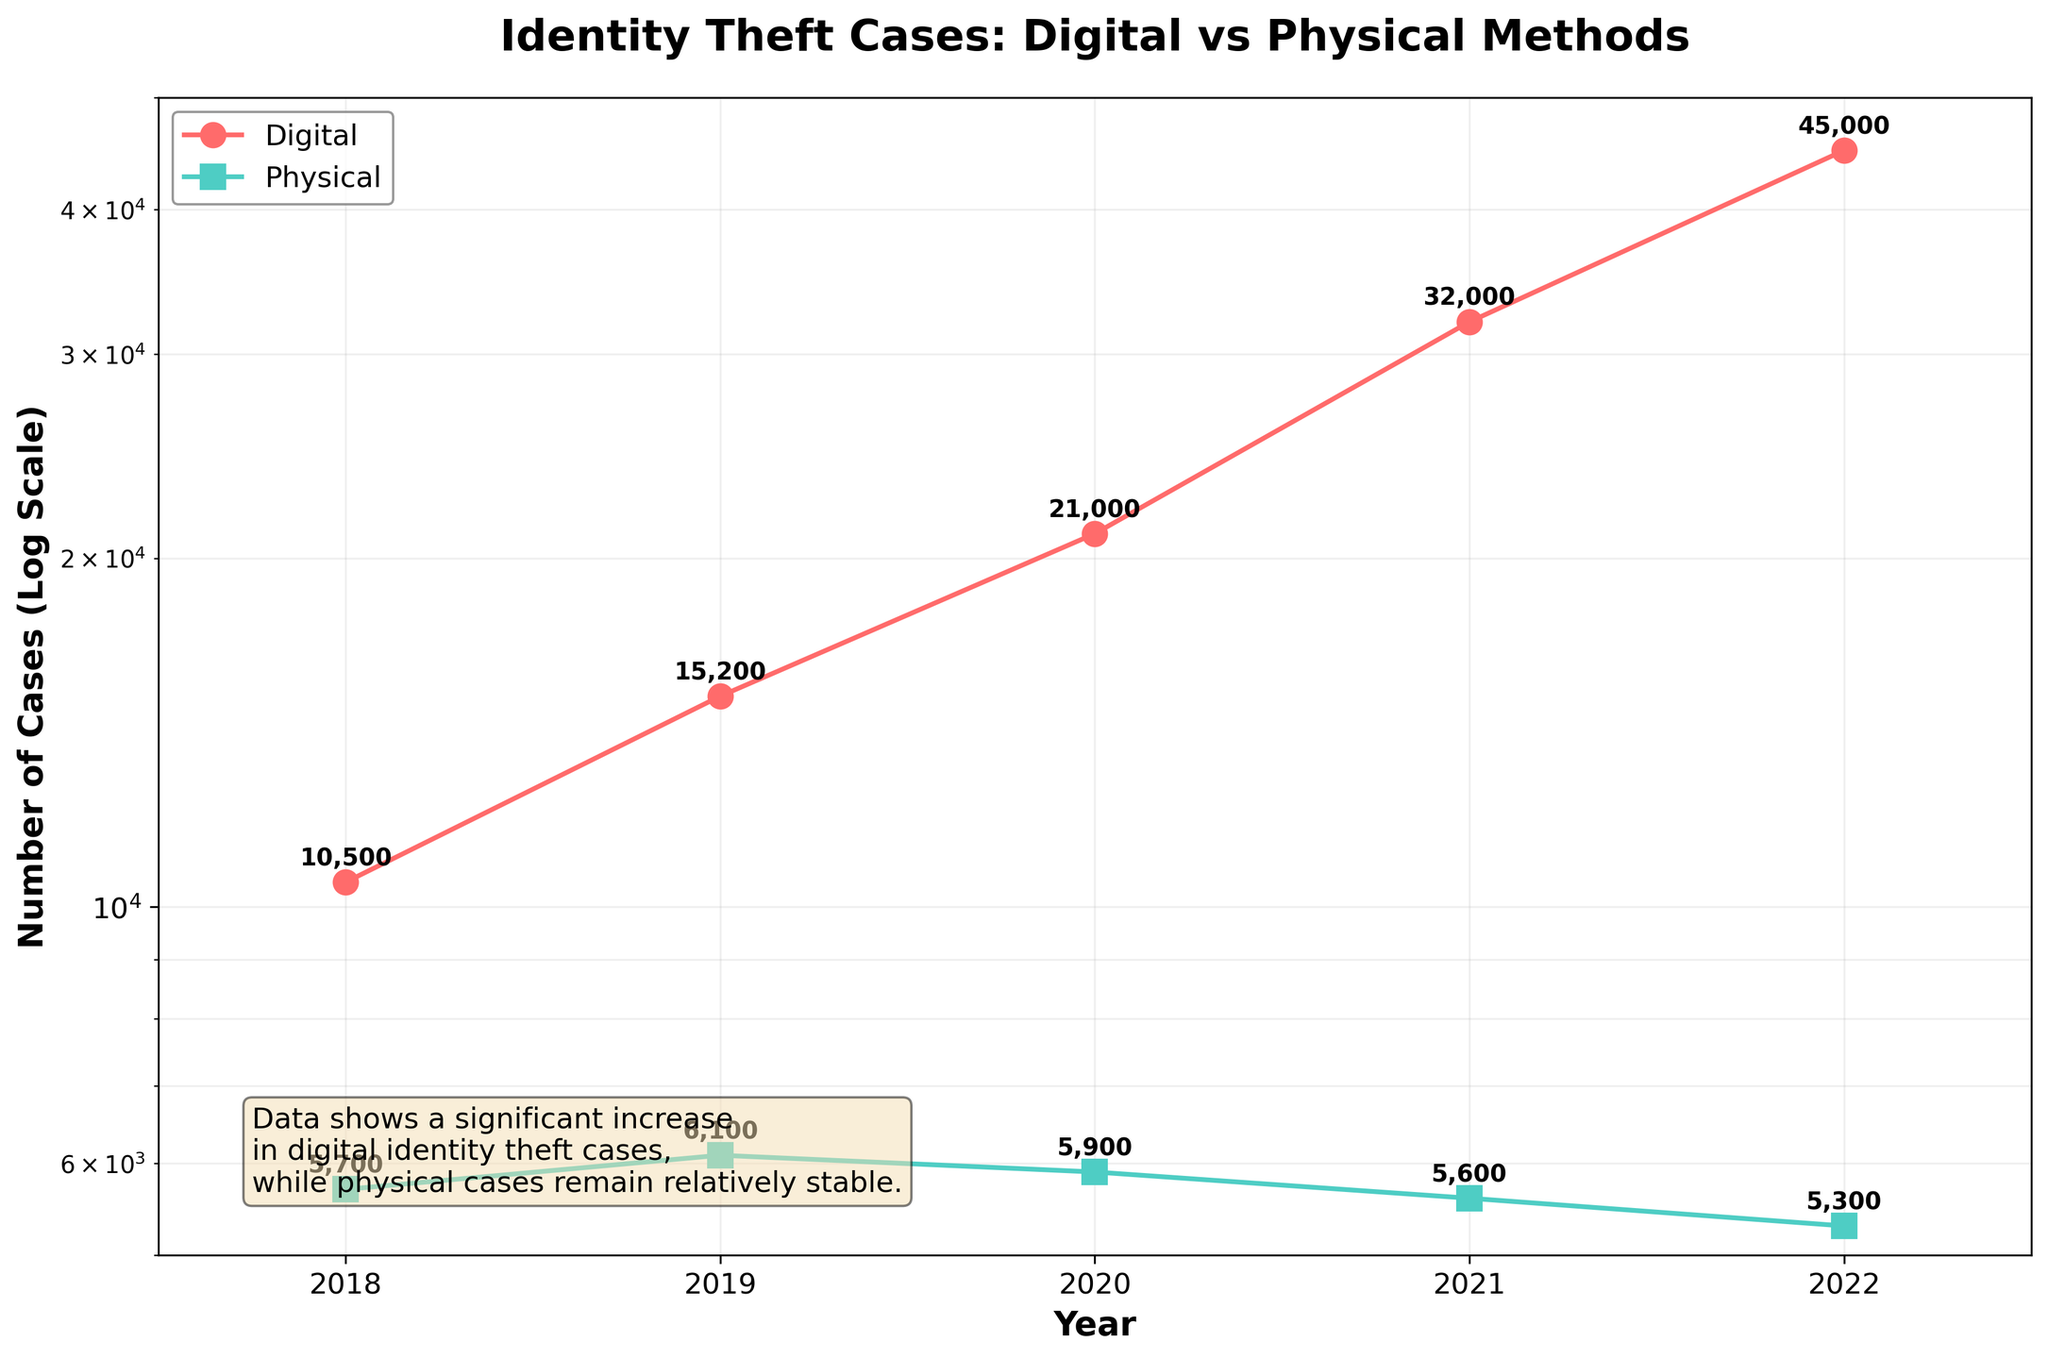What's the title of the plot? The title can be found at the top of the plot. It summarizes the subject of the visualization.
Answer: Identity Theft Cases: Digital vs Physical Methods What are the y-axis units on the plot? The y-axis uses a logarithmic scale to show the Number of Cases, as indicated by the axis label.
Answer: Log Scale How many years are covered in the plot? The x-axis labels indicate the range of years displayed in the plot. By counting these labels, we can determine the number of covered years.
Answer: 5 What colors represent Digital and Physical methods in the plot? The legend shows which colors correspond to each method.
Answer: Digital is red, Physical is green Which method had a higher number of cases in 2020? Compare the 2020 data points for both Digital and Physical methods using their specific colors and marked points.
Answer: Digital Calculate the difference in the number of Digital cases reported between 2021 and 2022. Subtract the number of cases in 2021 from the number in 2022 for the Digital data. 45000 - 32000 = 13000
Answer: 13000 What trend can you observe in the number of Physical identity theft cases from 2018 to 2022? Inspect the position of the data points for Physical methods from 2018 to 2022 and describe if they are increasing, decreasing, or stable.
Answer: Generally decreasing What is the average number of Digital identity theft cases reported from 2018 to 2022? Add up the number of Digital cases from each year and divide by the number of years. (10500 + 15200 + 21000 + 32000 + 45000) / 5 = 24740
Answer: 24740 What significant observation can be made about the Digital cases trend over the years? Analyze the plot's visual data for Digital cases and note the notable changes or trends.
Answer: Significant increase How does the trend of Digital identity theft cases compare to Physical cases from 2018 to 2022? Compare the trends of both methods visually over the years; note the differences in pattern or movement.
Answer: Digital increases sharply; Physical is relatively stable 